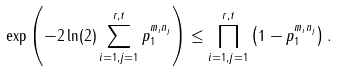Convert formula to latex. <formula><loc_0><loc_0><loc_500><loc_500>\exp \left ( - 2 \ln ( 2 ) \sum _ { i = 1 , j = 1 } ^ { r , t } p _ { 1 } ^ { m _ { i } n _ { j } } \right ) \leq \prod _ { i = 1 , j = 1 } ^ { r , t } \left ( 1 - p _ { 1 } ^ { m _ { i } n _ { j } } \right ) .</formula> 